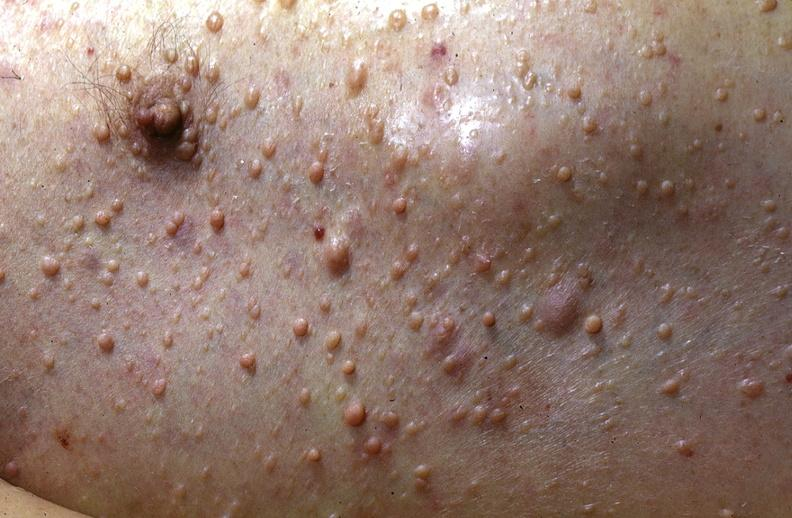does this image show skin, neurofibromatosis?
Answer the question using a single word or phrase. Yes 